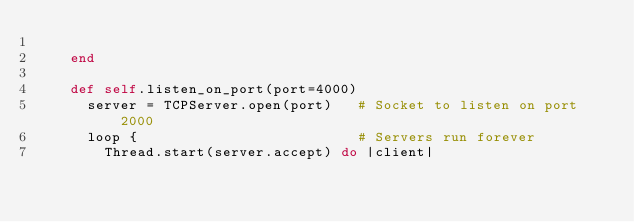<code> <loc_0><loc_0><loc_500><loc_500><_Ruby_>      
    end

    def self.listen_on_port(port=4000)
      server = TCPServer.open(port)   # Socket to listen on port 2000
      loop {                          # Servers run forever
        Thread.start(server.accept) do |client|</code> 